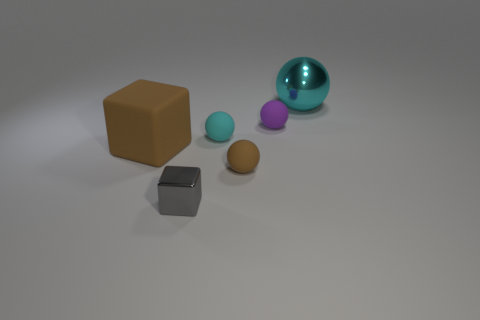Can you explain the lighting and shadows in the scene? The scene is illuminated with what appears to be soft, ambient lighting coming from above, casting gentle shadows directly underneath the objects. This lighting setup suggests an indoor environment, possibly a studio setup for a product photography shoot or a 3D rendering. 